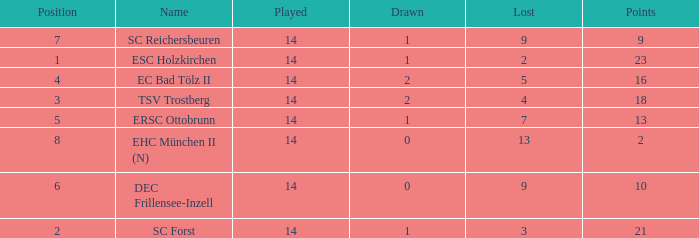Which Lost is the lowest one that has a Name of esc holzkirchen, and Played smaller than 14? None. 